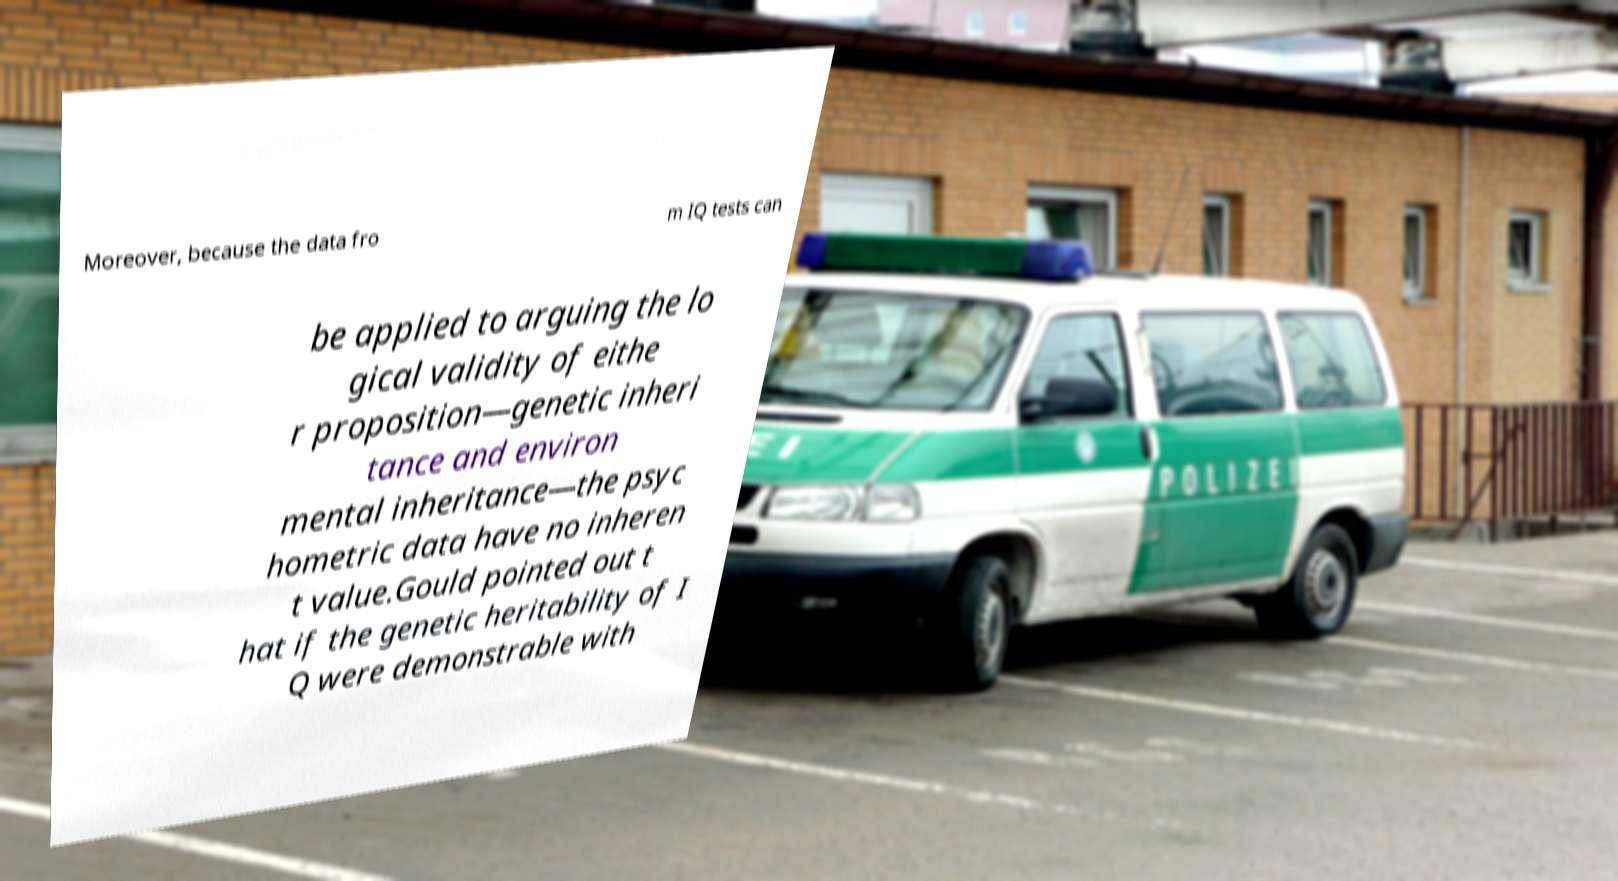Please identify and transcribe the text found in this image. Moreover, because the data fro m IQ tests can be applied to arguing the lo gical validity of eithe r proposition—genetic inheri tance and environ mental inheritance—the psyc hometric data have no inheren t value.Gould pointed out t hat if the genetic heritability of I Q were demonstrable with 